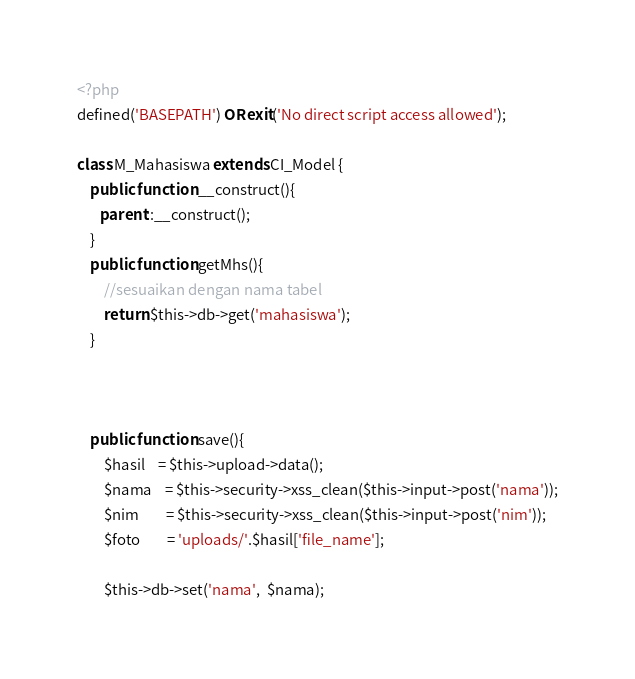<code> <loc_0><loc_0><loc_500><loc_500><_PHP_><?php
defined('BASEPATH') OR exit('No direct script access allowed');

class M_Mahasiswa extends CI_Model {
	public function __construct(){
       parent::__construct();
	}
	public function getMhs(){
        //sesuaikan dengan nama tabel
		return $this->db->get('mahasiswa');
	}



	public function save(){
		$hasil 	= $this->upload->data();
		$nama 	= $this->security->xss_clean($this->input->post('nama'));
        $nim 		= $this->security->xss_clean($this->input->post('nim'));
		$foto		= 'uploads/'.$hasil['file_name'];

		$this->db->set('nama',  $nama);</code> 